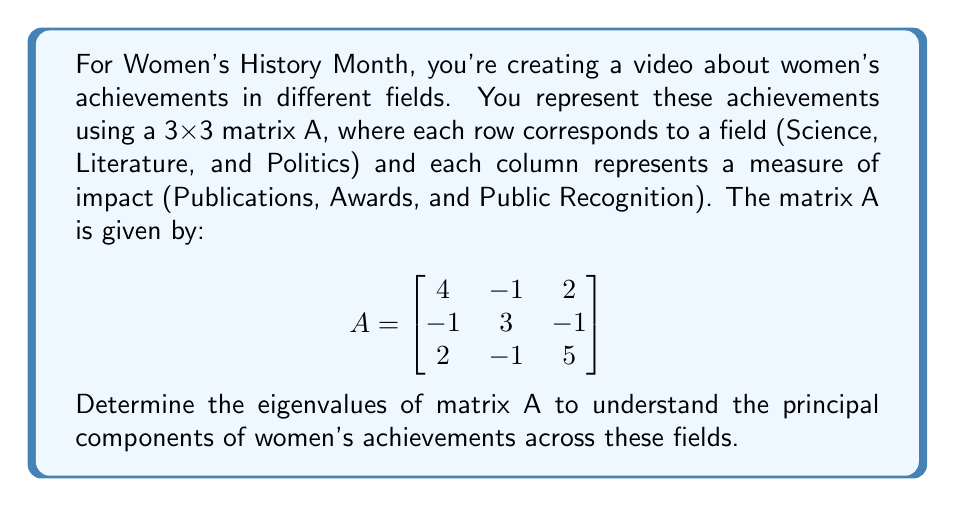Show me your answer to this math problem. To find the eigenvalues of matrix A, we need to solve the characteristic equation:

1) First, we set up the equation $det(A - \lambda I) = 0$, where $I$ is the 3x3 identity matrix and $\lambda$ represents the eigenvalues:

   $$det\begin{pmatrix}
   4-\lambda & -1 & 2 \\
   -1 & 3-\lambda & -1 \\
   2 & -1 & 5-\lambda
   \end{pmatrix} = 0$$

2) Expand the determinant:
   $(4-\lambda)[(3-\lambda)(5-\lambda) - 1] + (-1)[(-1)(5-\lambda) - 2(-1)] + 2[(-1)(-1) - (3-\lambda)(2)] = 0$

3) Simplify:
   $(4-\lambda)(15-8\lambda+\lambda^2-1) + (-1)(-5+\lambda+2) + 2(1-6+2\lambda) = 0$
   $(4-\lambda)(14-8\lambda+\lambda^2) + (-1)(-3+\lambda) + 2(-5+2\lambda) = 0$

4) Expand further:
   $56-32\lambda+4\lambda^2-14\lambda+8\lambda^2-\lambda^3 + 3-\lambda + -10+4\lambda = 0$

5) Collect like terms:
   $-\lambda^3 + 12\lambda^2 - 39\lambda + 49 = 0$

6) This is the characteristic polynomial. To find its roots (the eigenvalues), we can use the cubic formula or a computer algebra system. The roots are:

   $\lambda_1 = 7$
   $\lambda_2 = 3$
   $\lambda_3 = 2$

These eigenvalues represent the principal components of women's achievements across Science, Literature, and Politics in terms of Publications, Awards, and Public Recognition.
Answer: $\lambda_1 = 7, \lambda_2 = 3, \lambda_3 = 2$ 